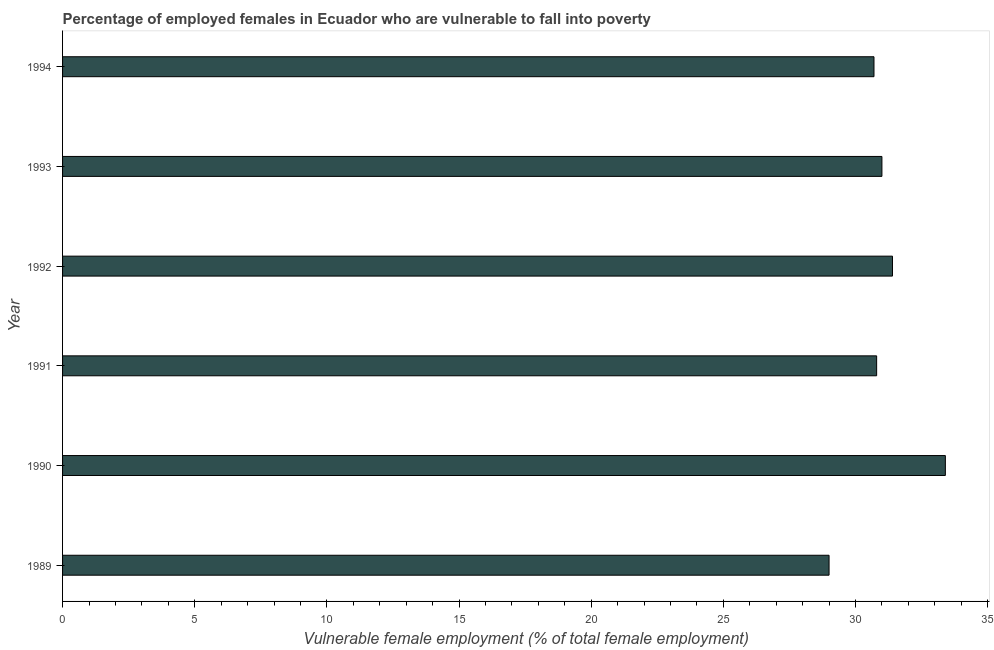Does the graph contain any zero values?
Make the answer very short. No. What is the title of the graph?
Offer a terse response. Percentage of employed females in Ecuador who are vulnerable to fall into poverty. What is the label or title of the X-axis?
Ensure brevity in your answer.  Vulnerable female employment (% of total female employment). What is the percentage of employed females who are vulnerable to fall into poverty in 1992?
Provide a succinct answer. 31.4. Across all years, what is the maximum percentage of employed females who are vulnerable to fall into poverty?
Your response must be concise. 33.4. In which year was the percentage of employed females who are vulnerable to fall into poverty minimum?
Ensure brevity in your answer.  1989. What is the sum of the percentage of employed females who are vulnerable to fall into poverty?
Provide a succinct answer. 186.3. What is the difference between the percentage of employed females who are vulnerable to fall into poverty in 1993 and 1994?
Your answer should be compact. 0.3. What is the average percentage of employed females who are vulnerable to fall into poverty per year?
Your response must be concise. 31.05. What is the median percentage of employed females who are vulnerable to fall into poverty?
Provide a short and direct response. 30.9. In how many years, is the percentage of employed females who are vulnerable to fall into poverty greater than 13 %?
Provide a short and direct response. 6. What is the ratio of the percentage of employed females who are vulnerable to fall into poverty in 1990 to that in 1994?
Give a very brief answer. 1.09. Is the percentage of employed females who are vulnerable to fall into poverty in 1989 less than that in 1992?
Provide a short and direct response. Yes. What is the difference between the highest and the second highest percentage of employed females who are vulnerable to fall into poverty?
Your response must be concise. 2. Is the sum of the percentage of employed females who are vulnerable to fall into poverty in 1990 and 1994 greater than the maximum percentage of employed females who are vulnerable to fall into poverty across all years?
Keep it short and to the point. Yes. In how many years, is the percentage of employed females who are vulnerable to fall into poverty greater than the average percentage of employed females who are vulnerable to fall into poverty taken over all years?
Your answer should be compact. 2. How many bars are there?
Provide a short and direct response. 6. What is the difference between two consecutive major ticks on the X-axis?
Your answer should be very brief. 5. What is the Vulnerable female employment (% of total female employment) of 1989?
Offer a very short reply. 29. What is the Vulnerable female employment (% of total female employment) in 1990?
Offer a terse response. 33.4. What is the Vulnerable female employment (% of total female employment) of 1991?
Provide a short and direct response. 30.8. What is the Vulnerable female employment (% of total female employment) of 1992?
Your answer should be very brief. 31.4. What is the Vulnerable female employment (% of total female employment) of 1994?
Make the answer very short. 30.7. What is the difference between the Vulnerable female employment (% of total female employment) in 1989 and 1990?
Provide a short and direct response. -4.4. What is the difference between the Vulnerable female employment (% of total female employment) in 1989 and 1993?
Give a very brief answer. -2. What is the difference between the Vulnerable female employment (% of total female employment) in 1990 and 1991?
Keep it short and to the point. 2.6. What is the difference between the Vulnerable female employment (% of total female employment) in 1991 and 1993?
Offer a very short reply. -0.2. What is the difference between the Vulnerable female employment (% of total female employment) in 1992 and 1994?
Keep it short and to the point. 0.7. What is the difference between the Vulnerable female employment (% of total female employment) in 1993 and 1994?
Offer a very short reply. 0.3. What is the ratio of the Vulnerable female employment (% of total female employment) in 1989 to that in 1990?
Your answer should be very brief. 0.87. What is the ratio of the Vulnerable female employment (% of total female employment) in 1989 to that in 1991?
Make the answer very short. 0.94. What is the ratio of the Vulnerable female employment (% of total female employment) in 1989 to that in 1992?
Offer a very short reply. 0.92. What is the ratio of the Vulnerable female employment (% of total female employment) in 1989 to that in 1993?
Make the answer very short. 0.94. What is the ratio of the Vulnerable female employment (% of total female employment) in 1989 to that in 1994?
Your answer should be very brief. 0.94. What is the ratio of the Vulnerable female employment (% of total female employment) in 1990 to that in 1991?
Provide a short and direct response. 1.08. What is the ratio of the Vulnerable female employment (% of total female employment) in 1990 to that in 1992?
Provide a succinct answer. 1.06. What is the ratio of the Vulnerable female employment (% of total female employment) in 1990 to that in 1993?
Make the answer very short. 1.08. What is the ratio of the Vulnerable female employment (% of total female employment) in 1990 to that in 1994?
Offer a terse response. 1.09. 